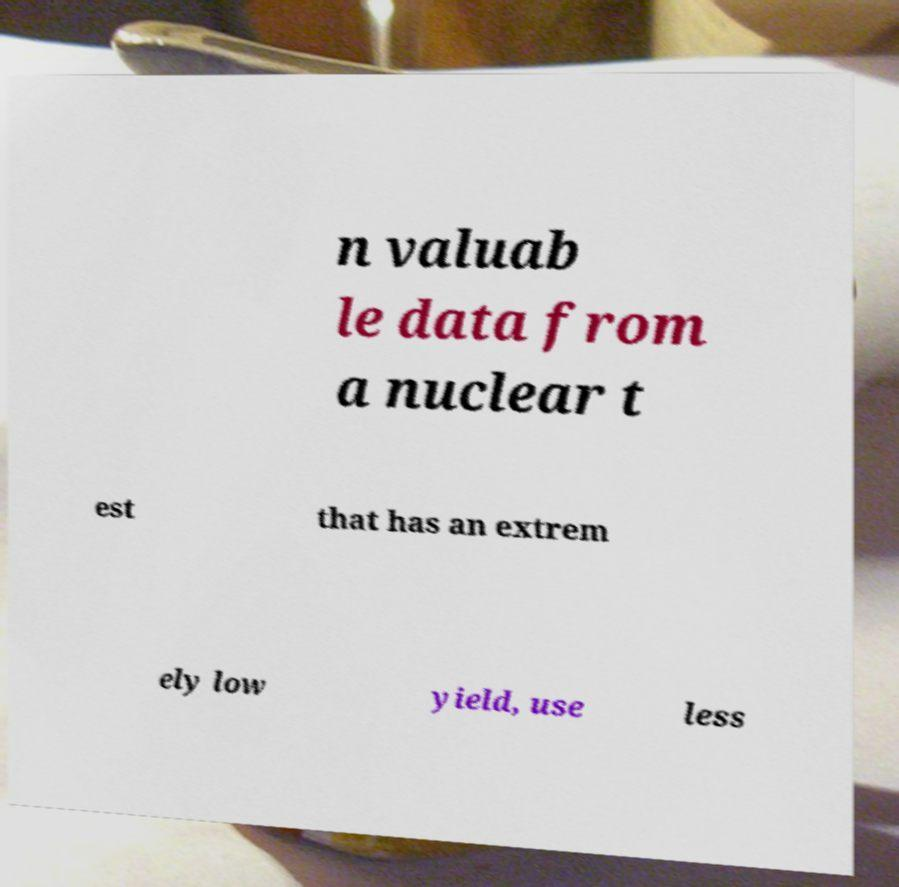Could you extract and type out the text from this image? n valuab le data from a nuclear t est that has an extrem ely low yield, use less 